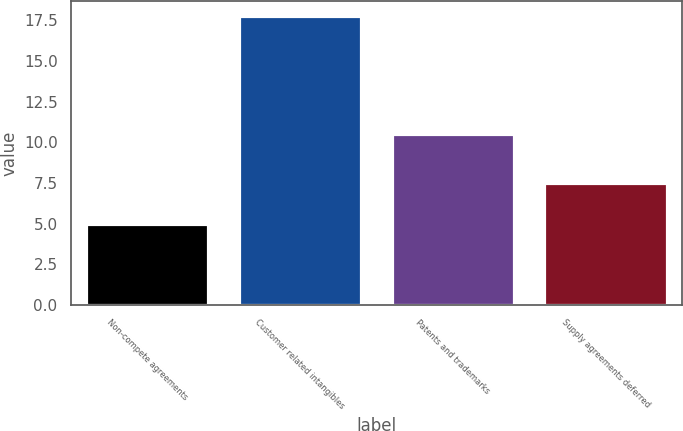Convert chart. <chart><loc_0><loc_0><loc_500><loc_500><bar_chart><fcel>Non-compete agreements<fcel>Customer related intangibles<fcel>Patents and trademarks<fcel>Supply agreements deferred<nl><fcel>5<fcel>17.8<fcel>10.5<fcel>7.5<nl></chart> 